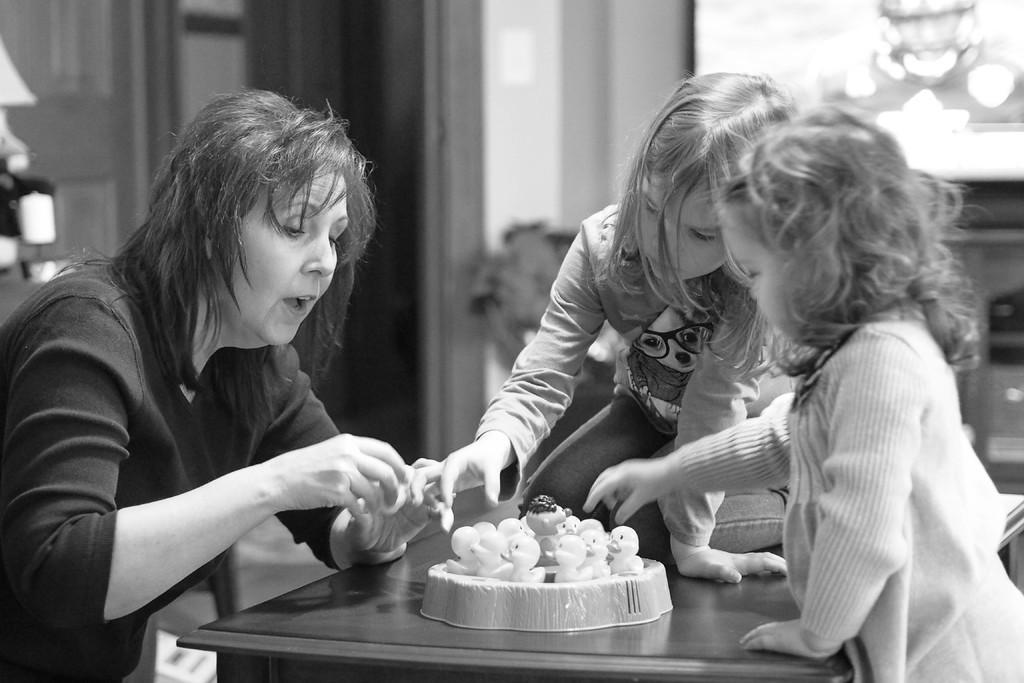Can you describe this image briefly? In the picture I can see a woman and two girls. I can also see a girl is sitting on a table. Here I can see a cake on a table. In the background I can see a wall. The background of the image is blurred. This picture is black and white in color. 